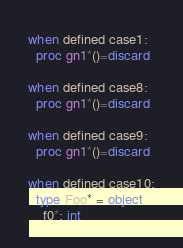Convert code to text. <code><loc_0><loc_0><loc_500><loc_500><_Nim_>when defined case1:
  proc gn1*()=discard

when defined case8:
  proc gn1*()=discard

when defined case9:
  proc gn1*()=discard

when defined case10:
  type Foo* = object
    f0*: int
</code> 